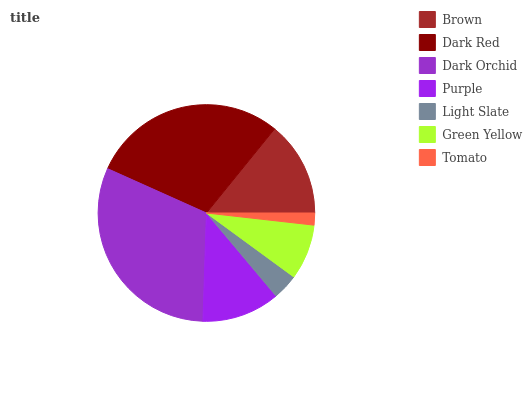Is Tomato the minimum?
Answer yes or no. Yes. Is Dark Orchid the maximum?
Answer yes or no. Yes. Is Dark Red the minimum?
Answer yes or no. No. Is Dark Red the maximum?
Answer yes or no. No. Is Dark Red greater than Brown?
Answer yes or no. Yes. Is Brown less than Dark Red?
Answer yes or no. Yes. Is Brown greater than Dark Red?
Answer yes or no. No. Is Dark Red less than Brown?
Answer yes or no. No. Is Purple the high median?
Answer yes or no. Yes. Is Purple the low median?
Answer yes or no. Yes. Is Dark Orchid the high median?
Answer yes or no. No. Is Light Slate the low median?
Answer yes or no. No. 